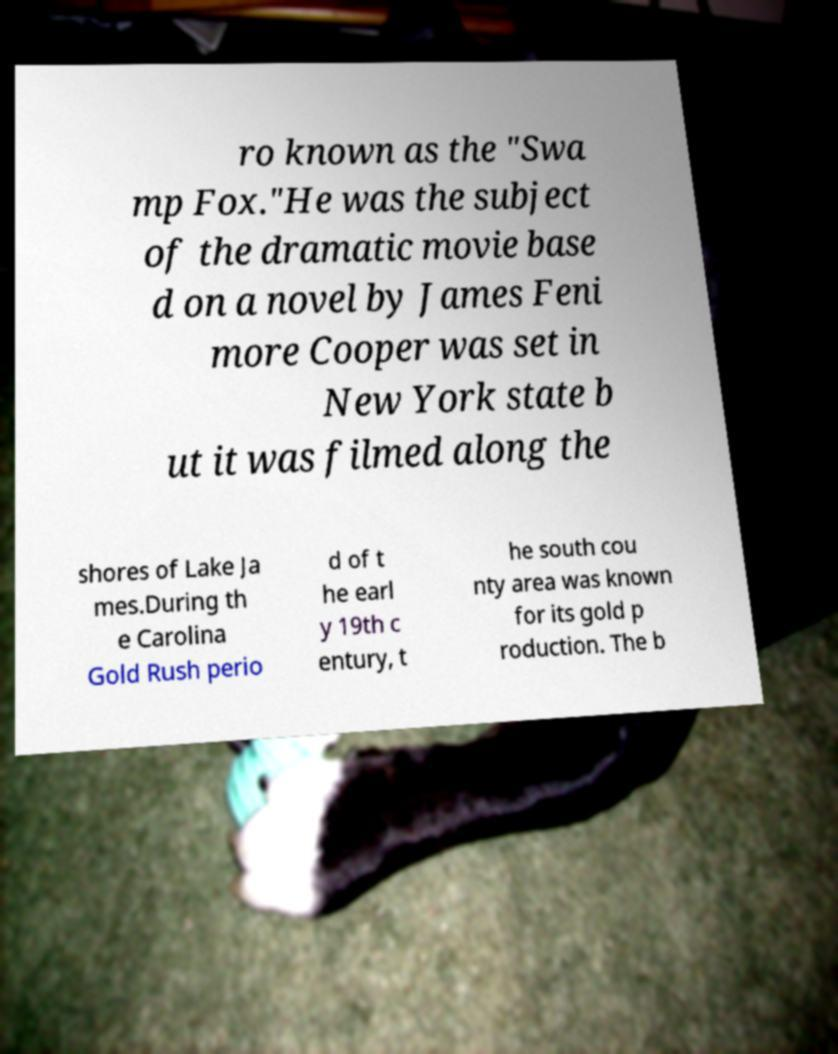Can you read and provide the text displayed in the image?This photo seems to have some interesting text. Can you extract and type it out for me? ro known as the "Swa mp Fox."He was the subject of the dramatic movie base d on a novel by James Feni more Cooper was set in New York state b ut it was filmed along the shores of Lake Ja mes.During th e Carolina Gold Rush perio d of t he earl y 19th c entury, t he south cou nty area was known for its gold p roduction. The b 